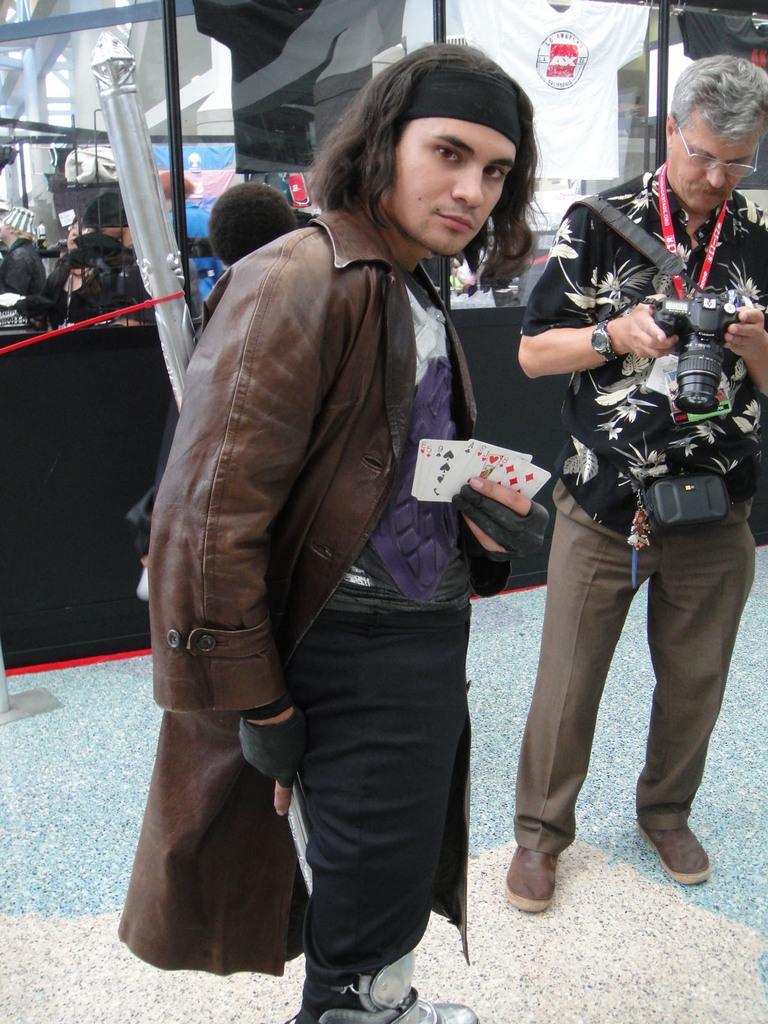Could you give a brief overview of what you see in this image? This picture is taken outside a city on the pavement. In the center of the picture there is a man in brown jacket holding cards. On the right there is a man standing holding a camera. In the background there is a glass and t-shirts are hanging. 